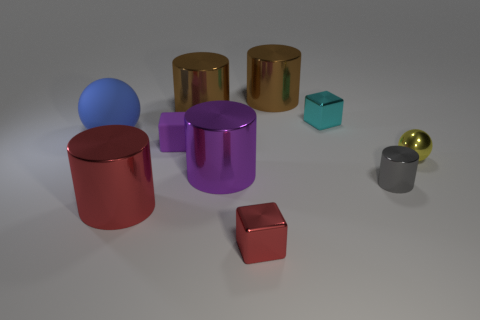Subtract all tiny cylinders. How many cylinders are left? 4 Subtract all spheres. How many objects are left? 8 Subtract 2 cubes. How many cubes are left? 1 Subtract all blue spheres. Subtract all purple cylinders. How many spheres are left? 1 Subtract all cyan cubes. How many yellow balls are left? 1 Subtract all gray metal things. Subtract all big balls. How many objects are left? 8 Add 5 red metallic cubes. How many red metallic cubes are left? 6 Add 7 big gray balls. How many big gray balls exist? 7 Subtract all cyan cubes. How many cubes are left? 2 Subtract 1 gray cylinders. How many objects are left? 9 